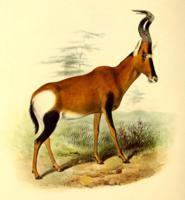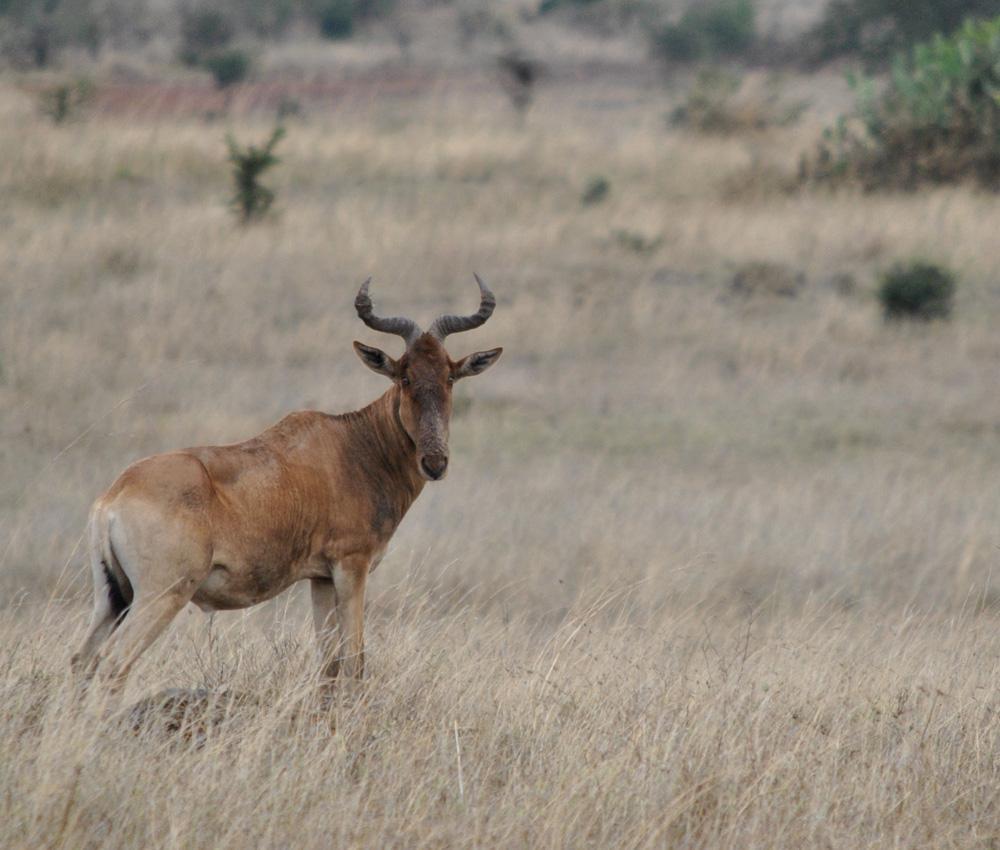The first image is the image on the left, the second image is the image on the right. Evaluate the accuracy of this statement regarding the images: "The animal in the image on the right is standing in side profile with its head turned toward the camera.". Is it true? Answer yes or no. Yes. 